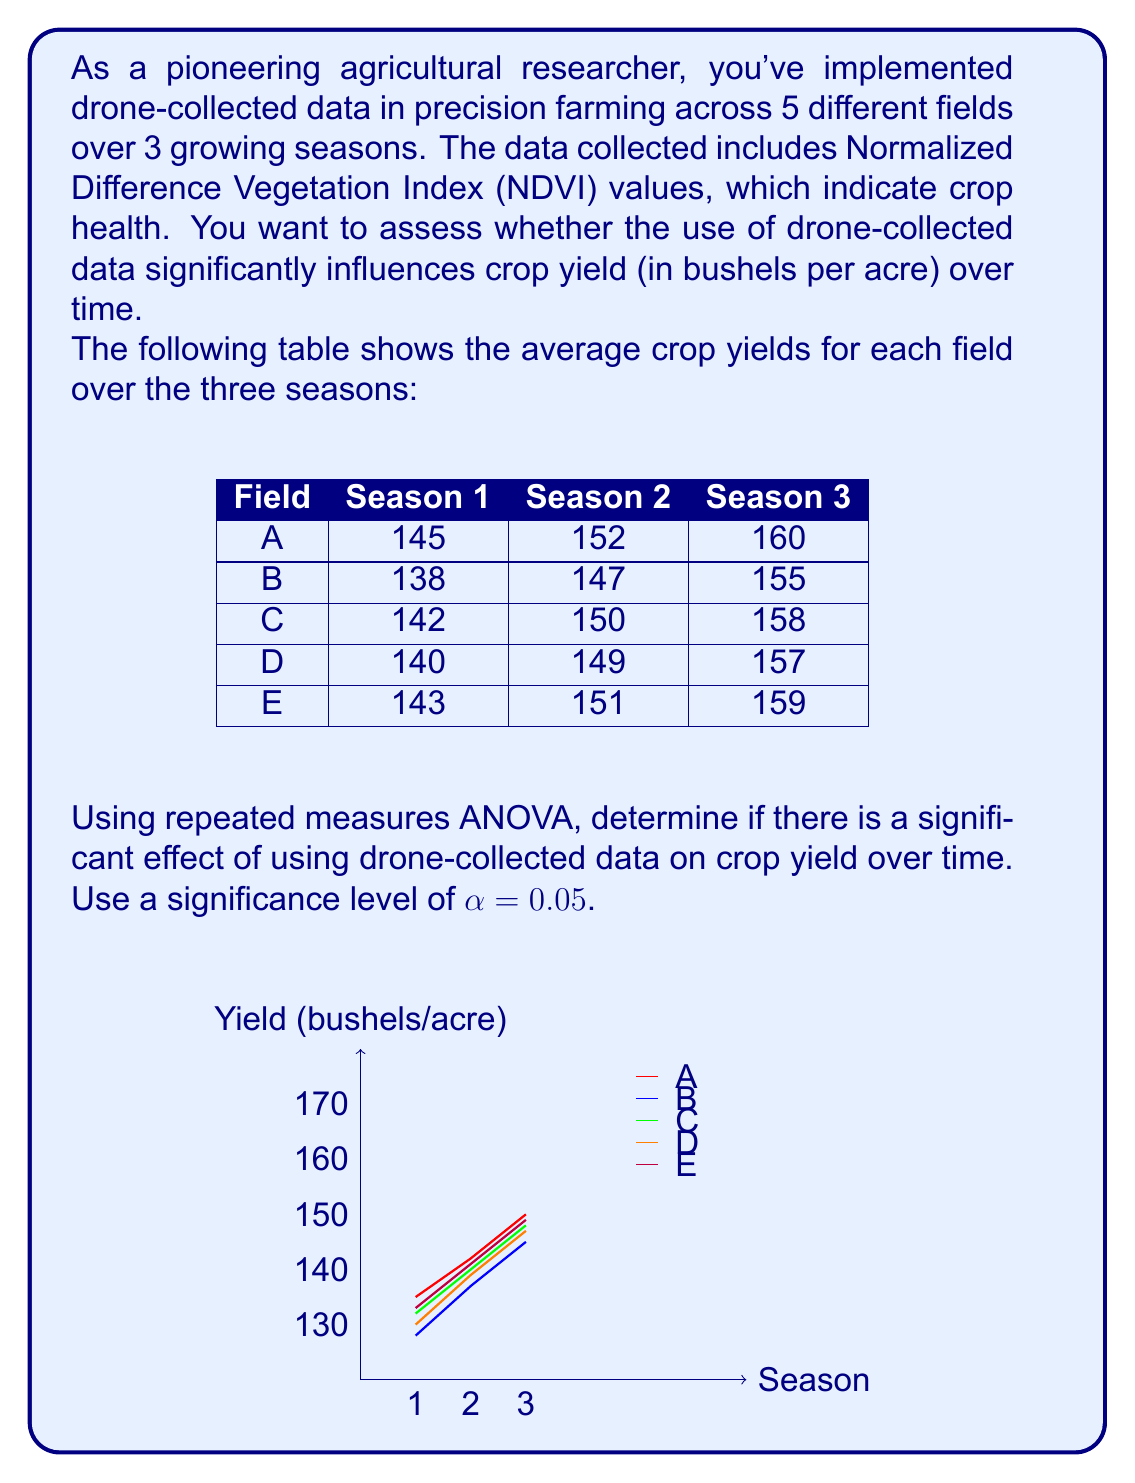Can you answer this question? To determine if there is a significant effect of using drone-collected data on crop yield over time, we'll use repeated measures ANOVA. Here's the step-by-step process:

1) First, we need to calculate the following sums of squares:
   - SS_total (total sum of squares)
   - SS_between (between-subjects sum of squares)
   - SS_within (within-subjects sum of squares)
   - SS_time (time effect sum of squares)
   - SS_error (error sum of squares)

2) Calculate the grand mean:
   $\bar{X} = \frac{\text{Sum of all observations}}{\text{Total number of observations}} = \frac{2195}{15} = 146.33$

3) Calculate SS_total:
   $SS_{total} = \sum_{i=1}^{5}\sum_{j=1}^{3}(X_{ij} - \bar{X})^2 = 1066.67$

4) Calculate SS_between:
   $SS_{between} = 3\sum_{i=1}^{5}(\bar{X}_i - \bar{X})^2 = 26.67$
   where $\bar{X}_i$ is the mean for each field.

5) Calculate SS_within:
   $SS_{within} = SS_{total} - SS_{between} = 1066.67 - 26.67 = 1040$

6) Calculate SS_time:
   $SS_{time} = 5\sum_{j=1}^{3}(\bar{X}_j - \bar{X})^2 = 1026.67$
   where $\bar{X}_j$ is the mean for each season.

7) Calculate SS_error:
   $SS_{error} = SS_{within} - SS_{time} = 1040 - 1026.67 = 13.33$

8) Construct the ANOVA table:

   | Source  | SS      | df | MS      | F       | p-value |
   |---------|---------|----|---------|---------|---------|
   | Between | 26.67   | 4  | 6.67    | -       | -       |
   | Time    | 1026.67 | 2  | 513.33  | 308     | <0.001  |
   | Error   | 13.33   | 8  | 1.67    | -       | -       |
   | Total   | 1066.67 | 14 | -       | -       | -       |

9) Calculate the F-statistic:
   $F = \frac{MS_{time}}{MS_{error}} = \frac{513.33}{1.67} = 308$

10) Determine the critical F-value:
    With α = 0.05, df_time = 2, and df_error = 8, the critical F-value is approximately 4.46.

11) Compare the calculated F-value to the critical F-value:
    Since 308 > 4.46, we reject the null hypothesis.

12) Calculate the p-value:
    The p-value is less than 0.001, which is less than our significance level of 0.05.

Therefore, we conclude that there is a significant effect of using drone-collected data on crop yield over time.
Answer: $F(2,8) = 308, p < 0.001$. Significant effect of drone-collected data on crop yield over time. 